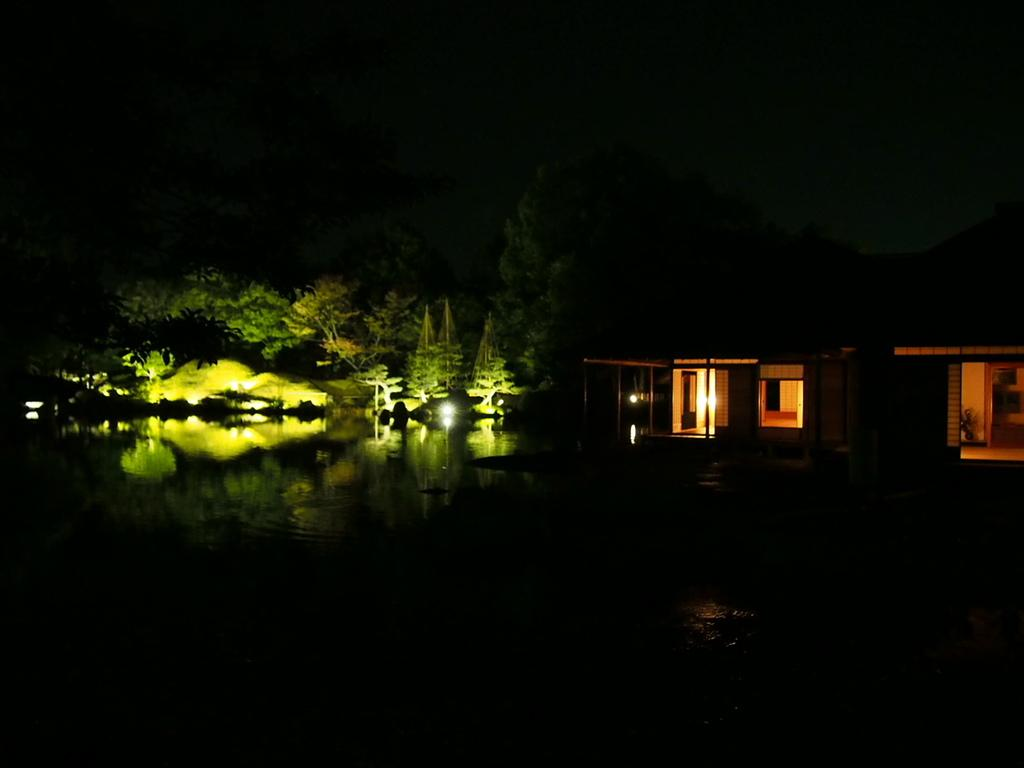What type of structure is present in the image? There is a building in the image. What can be seen illuminated in the image? There are lights visible in the image. What type of vegetation is present in the image? There is a group of trees in the image. What natural element is present in the image? There is a water body in the image. What is visible at the top of the image? The sky is visible in the image. What type of reward is being given to the thumb in the image? There is no thumb or reward present in the image. What is the desire of the person in the image? There is no person or desire mentioned in the image; it only features a building, lights, trees, a water body, and the sky. 